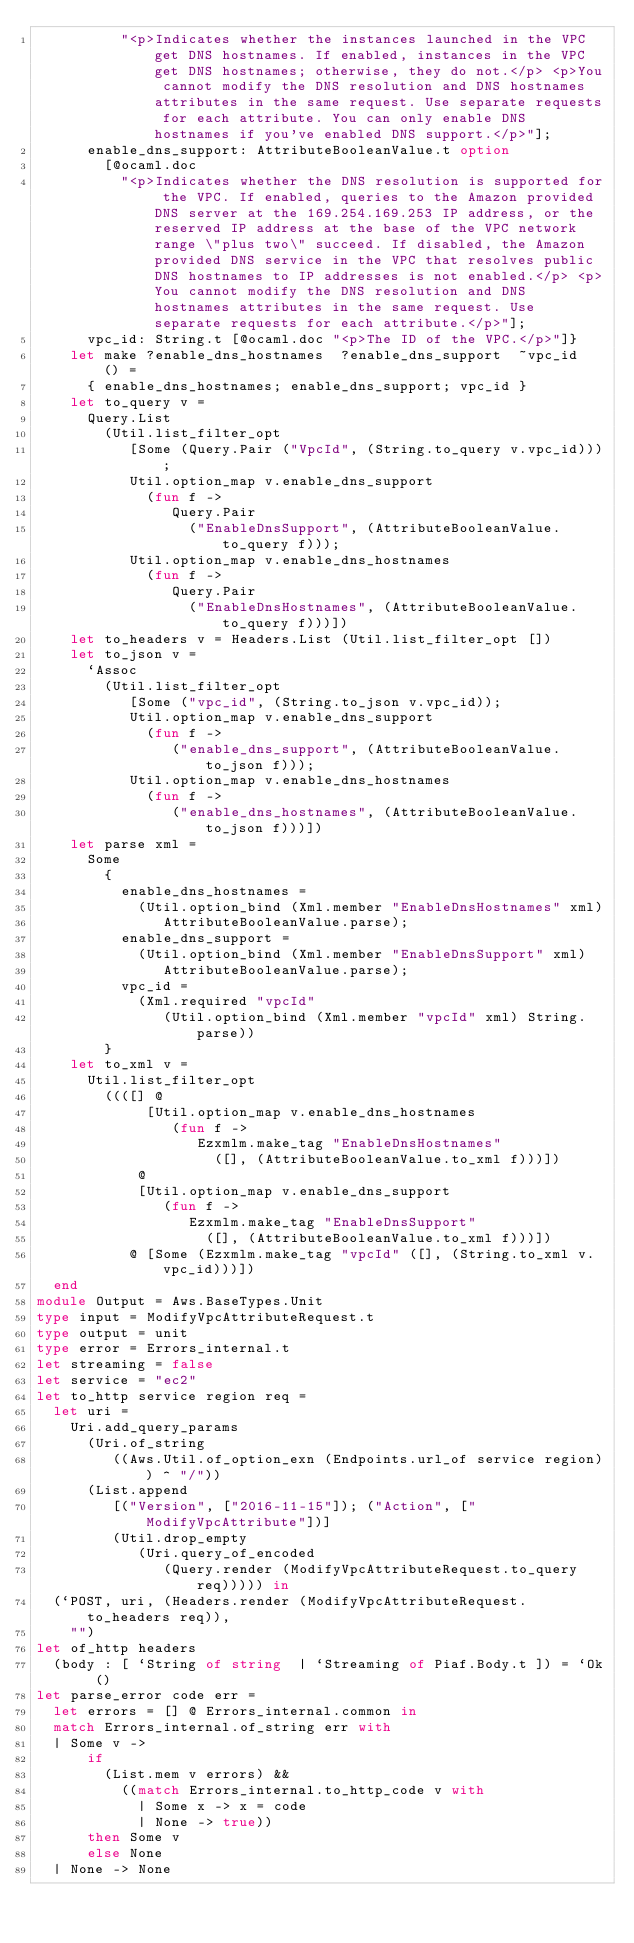Convert code to text. <code><loc_0><loc_0><loc_500><loc_500><_OCaml_>          "<p>Indicates whether the instances launched in the VPC get DNS hostnames. If enabled, instances in the VPC get DNS hostnames; otherwise, they do not.</p> <p>You cannot modify the DNS resolution and DNS hostnames attributes in the same request. Use separate requests for each attribute. You can only enable DNS hostnames if you've enabled DNS support.</p>"];
      enable_dns_support: AttributeBooleanValue.t option
        [@ocaml.doc
          "<p>Indicates whether the DNS resolution is supported for the VPC. If enabled, queries to the Amazon provided DNS server at the 169.254.169.253 IP address, or the reserved IP address at the base of the VPC network range \"plus two\" succeed. If disabled, the Amazon provided DNS service in the VPC that resolves public DNS hostnames to IP addresses is not enabled.</p> <p>You cannot modify the DNS resolution and DNS hostnames attributes in the same request. Use separate requests for each attribute.</p>"];
      vpc_id: String.t [@ocaml.doc "<p>The ID of the VPC.</p>"]}
    let make ?enable_dns_hostnames  ?enable_dns_support  ~vpc_id  () =
      { enable_dns_hostnames; enable_dns_support; vpc_id }
    let to_query v =
      Query.List
        (Util.list_filter_opt
           [Some (Query.Pair ("VpcId", (String.to_query v.vpc_id)));
           Util.option_map v.enable_dns_support
             (fun f ->
                Query.Pair
                  ("EnableDnsSupport", (AttributeBooleanValue.to_query f)));
           Util.option_map v.enable_dns_hostnames
             (fun f ->
                Query.Pair
                  ("EnableDnsHostnames", (AttributeBooleanValue.to_query f)))])
    let to_headers v = Headers.List (Util.list_filter_opt [])
    let to_json v =
      `Assoc
        (Util.list_filter_opt
           [Some ("vpc_id", (String.to_json v.vpc_id));
           Util.option_map v.enable_dns_support
             (fun f ->
                ("enable_dns_support", (AttributeBooleanValue.to_json f)));
           Util.option_map v.enable_dns_hostnames
             (fun f ->
                ("enable_dns_hostnames", (AttributeBooleanValue.to_json f)))])
    let parse xml =
      Some
        {
          enable_dns_hostnames =
            (Util.option_bind (Xml.member "EnableDnsHostnames" xml)
               AttributeBooleanValue.parse);
          enable_dns_support =
            (Util.option_bind (Xml.member "EnableDnsSupport" xml)
               AttributeBooleanValue.parse);
          vpc_id =
            (Xml.required "vpcId"
               (Util.option_bind (Xml.member "vpcId" xml) String.parse))
        }
    let to_xml v =
      Util.list_filter_opt
        ((([] @
             [Util.option_map v.enable_dns_hostnames
                (fun f ->
                   Ezxmlm.make_tag "EnableDnsHostnames"
                     ([], (AttributeBooleanValue.to_xml f)))])
            @
            [Util.option_map v.enable_dns_support
               (fun f ->
                  Ezxmlm.make_tag "EnableDnsSupport"
                    ([], (AttributeBooleanValue.to_xml f)))])
           @ [Some (Ezxmlm.make_tag "vpcId" ([], (String.to_xml v.vpc_id)))])
  end
module Output = Aws.BaseTypes.Unit
type input = ModifyVpcAttributeRequest.t
type output = unit
type error = Errors_internal.t
let streaming = false
let service = "ec2"
let to_http service region req =
  let uri =
    Uri.add_query_params
      (Uri.of_string
         ((Aws.Util.of_option_exn (Endpoints.url_of service region)) ^ "/"))
      (List.append
         [("Version", ["2016-11-15"]); ("Action", ["ModifyVpcAttribute"])]
         (Util.drop_empty
            (Uri.query_of_encoded
               (Query.render (ModifyVpcAttributeRequest.to_query req))))) in
  (`POST, uri, (Headers.render (ModifyVpcAttributeRequest.to_headers req)),
    "")
let of_http headers
  (body : [ `String of string  | `Streaming of Piaf.Body.t ]) = `Ok ()
let parse_error code err =
  let errors = [] @ Errors_internal.common in
  match Errors_internal.of_string err with
  | Some v ->
      if
        (List.mem v errors) &&
          ((match Errors_internal.to_http_code v with
            | Some x -> x = code
            | None -> true))
      then Some v
      else None
  | None -> None</code> 